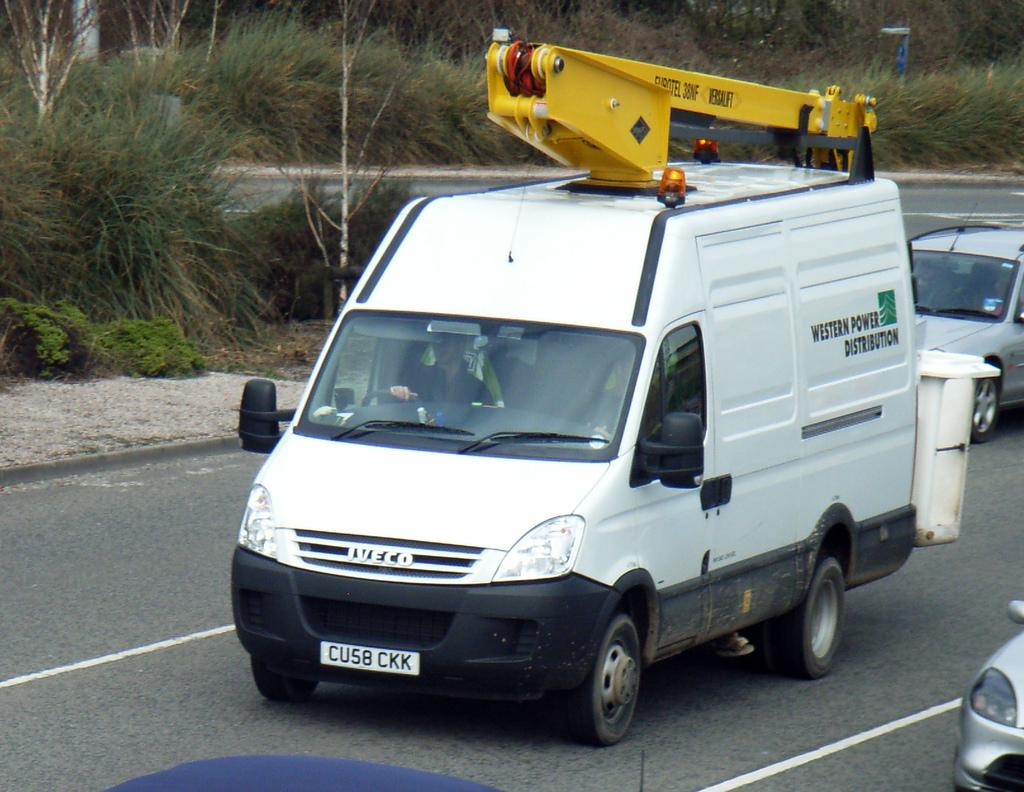<image>
Write a terse but informative summary of the picture. An Iveco brand work truck has a yellow device on the top. 